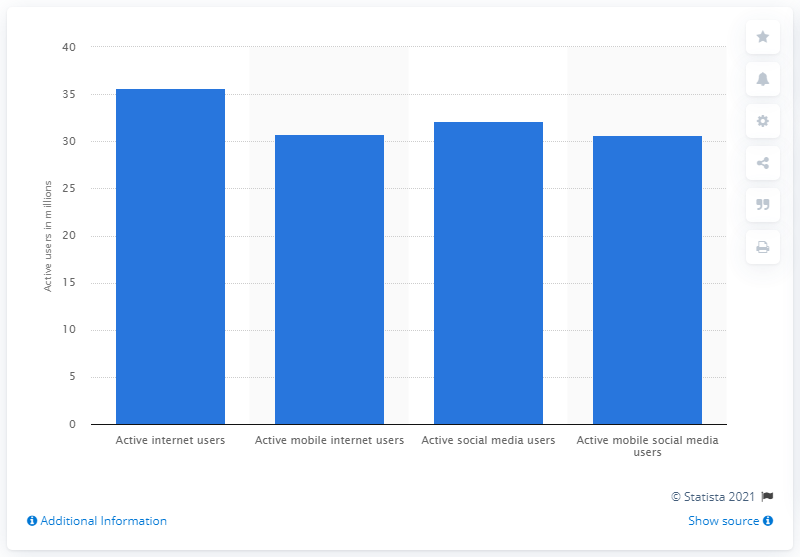Highlight a few significant elements in this photo. As of January 2021, the number of internet users in Canada was 35.63 million. In January 2021, there were approximately 30.75 mobile internet users in Canada. 